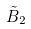<formula> <loc_0><loc_0><loc_500><loc_500>\tilde { B } _ { 2 }</formula> 